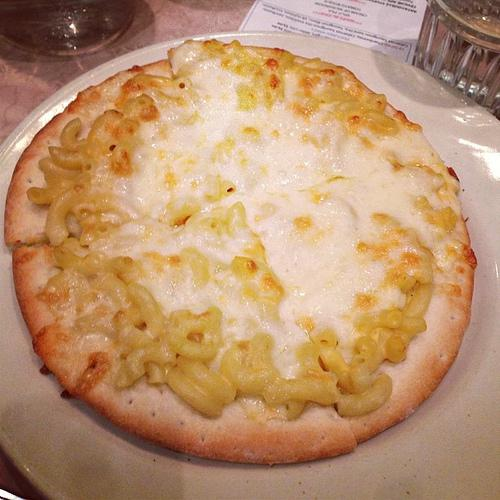Question: what color crust does the pizza have?
Choices:
A. Black.
B. Brown.
C. Tan.
D. Grey.
Answer with the letter. Answer: B Question: what type of food is pictured?
Choices:
A. Tacos.
B. Pizza.
C. Pasta.
D. Sandwich.
Answer with the letter. Answer: B Question: what color cheese is on the pizza?
Choices:
A. White.
B. Yellow.
C. Orange.
D. Red.
Answer with the letter. Answer: A Question: how many slices are on the pizza?
Choices:
A. Six.
B. Eight.
C. Ten.
D. Four.
Answer with the letter. Answer: D Question: what color plate is under the pizza?
Choices:
A. Blue.
B. Red.
C. White.
D. Green.
Answer with the letter. Answer: C 